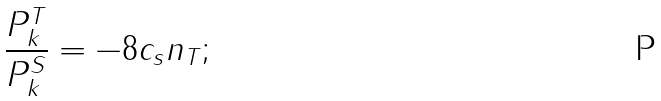<formula> <loc_0><loc_0><loc_500><loc_500>\frac { P ^ { T } _ { k } } { P ^ { S } _ { k } } = - 8 c _ { s } n _ { T } ;</formula> 